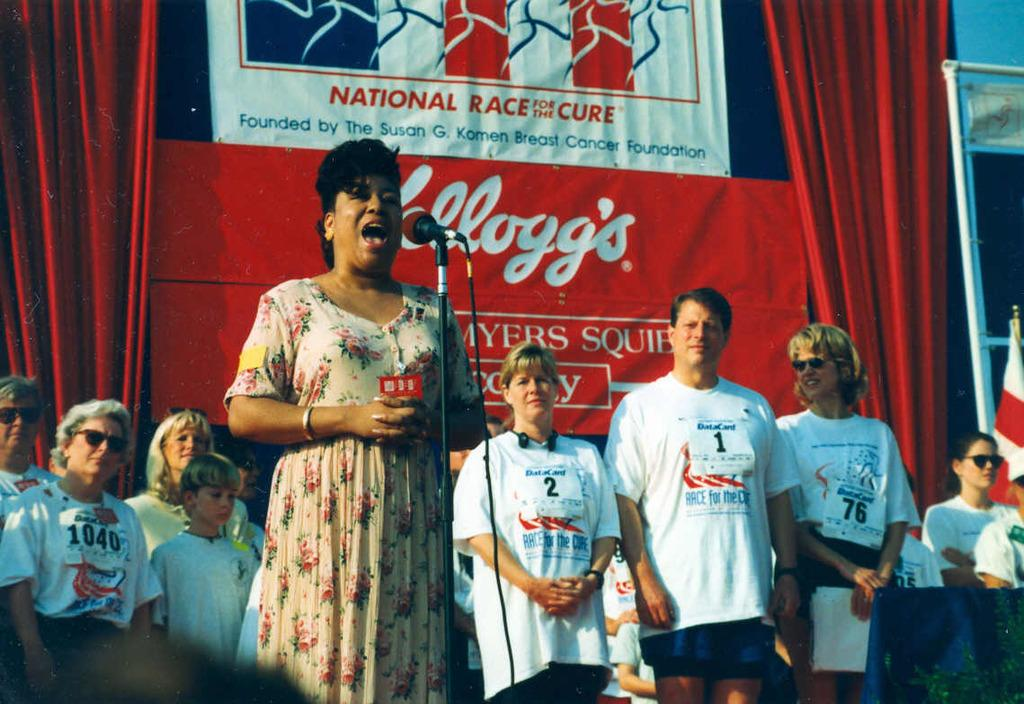<image>
Provide a brief description of the given image. A woman singing at the National Race for the Cure 